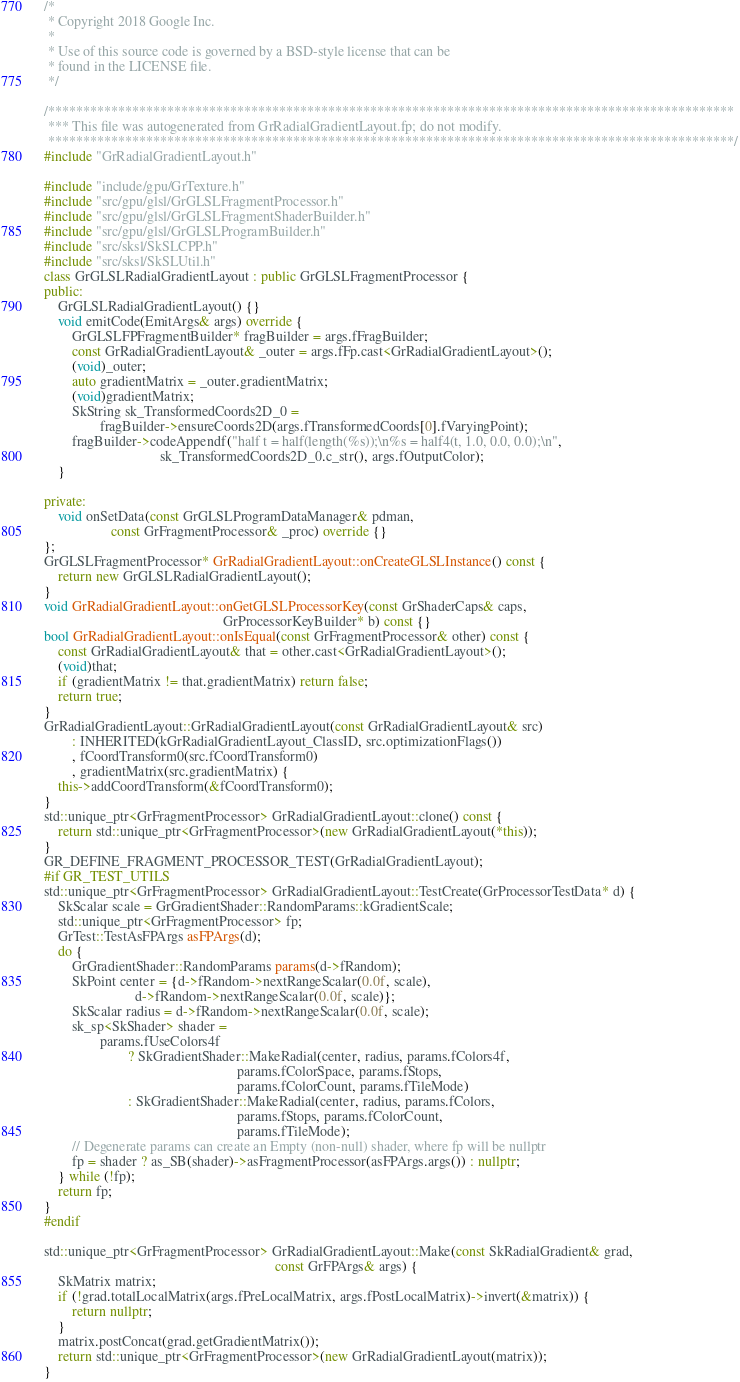<code> <loc_0><loc_0><loc_500><loc_500><_C++_>/*
 * Copyright 2018 Google Inc.
 *
 * Use of this source code is governed by a BSD-style license that can be
 * found in the LICENSE file.
 */

/**************************************************************************************************
 *** This file was autogenerated from GrRadialGradientLayout.fp; do not modify.
 **************************************************************************************************/
#include "GrRadialGradientLayout.h"

#include "include/gpu/GrTexture.h"
#include "src/gpu/glsl/GrGLSLFragmentProcessor.h"
#include "src/gpu/glsl/GrGLSLFragmentShaderBuilder.h"
#include "src/gpu/glsl/GrGLSLProgramBuilder.h"
#include "src/sksl/SkSLCPP.h"
#include "src/sksl/SkSLUtil.h"
class GrGLSLRadialGradientLayout : public GrGLSLFragmentProcessor {
public:
    GrGLSLRadialGradientLayout() {}
    void emitCode(EmitArgs& args) override {
        GrGLSLFPFragmentBuilder* fragBuilder = args.fFragBuilder;
        const GrRadialGradientLayout& _outer = args.fFp.cast<GrRadialGradientLayout>();
        (void)_outer;
        auto gradientMatrix = _outer.gradientMatrix;
        (void)gradientMatrix;
        SkString sk_TransformedCoords2D_0 =
                fragBuilder->ensureCoords2D(args.fTransformedCoords[0].fVaryingPoint);
        fragBuilder->codeAppendf("half t = half(length(%s));\n%s = half4(t, 1.0, 0.0, 0.0);\n",
                                 sk_TransformedCoords2D_0.c_str(), args.fOutputColor);
    }

private:
    void onSetData(const GrGLSLProgramDataManager& pdman,
                   const GrFragmentProcessor& _proc) override {}
};
GrGLSLFragmentProcessor* GrRadialGradientLayout::onCreateGLSLInstance() const {
    return new GrGLSLRadialGradientLayout();
}
void GrRadialGradientLayout::onGetGLSLProcessorKey(const GrShaderCaps& caps,
                                                   GrProcessorKeyBuilder* b) const {}
bool GrRadialGradientLayout::onIsEqual(const GrFragmentProcessor& other) const {
    const GrRadialGradientLayout& that = other.cast<GrRadialGradientLayout>();
    (void)that;
    if (gradientMatrix != that.gradientMatrix) return false;
    return true;
}
GrRadialGradientLayout::GrRadialGradientLayout(const GrRadialGradientLayout& src)
        : INHERITED(kGrRadialGradientLayout_ClassID, src.optimizationFlags())
        , fCoordTransform0(src.fCoordTransform0)
        , gradientMatrix(src.gradientMatrix) {
    this->addCoordTransform(&fCoordTransform0);
}
std::unique_ptr<GrFragmentProcessor> GrRadialGradientLayout::clone() const {
    return std::unique_ptr<GrFragmentProcessor>(new GrRadialGradientLayout(*this));
}
GR_DEFINE_FRAGMENT_PROCESSOR_TEST(GrRadialGradientLayout);
#if GR_TEST_UTILS
std::unique_ptr<GrFragmentProcessor> GrRadialGradientLayout::TestCreate(GrProcessorTestData* d) {
    SkScalar scale = GrGradientShader::RandomParams::kGradientScale;
    std::unique_ptr<GrFragmentProcessor> fp;
    GrTest::TestAsFPArgs asFPArgs(d);
    do {
        GrGradientShader::RandomParams params(d->fRandom);
        SkPoint center = {d->fRandom->nextRangeScalar(0.0f, scale),
                          d->fRandom->nextRangeScalar(0.0f, scale)};
        SkScalar radius = d->fRandom->nextRangeScalar(0.0f, scale);
        sk_sp<SkShader> shader =
                params.fUseColors4f
                        ? SkGradientShader::MakeRadial(center, radius, params.fColors4f,
                                                       params.fColorSpace, params.fStops,
                                                       params.fColorCount, params.fTileMode)
                        : SkGradientShader::MakeRadial(center, radius, params.fColors,
                                                       params.fStops, params.fColorCount,
                                                       params.fTileMode);
        // Degenerate params can create an Empty (non-null) shader, where fp will be nullptr
        fp = shader ? as_SB(shader)->asFragmentProcessor(asFPArgs.args()) : nullptr;
    } while (!fp);
    return fp;
}
#endif

std::unique_ptr<GrFragmentProcessor> GrRadialGradientLayout::Make(const SkRadialGradient& grad,
                                                                  const GrFPArgs& args) {
    SkMatrix matrix;
    if (!grad.totalLocalMatrix(args.fPreLocalMatrix, args.fPostLocalMatrix)->invert(&matrix)) {
        return nullptr;
    }
    matrix.postConcat(grad.getGradientMatrix());
    return std::unique_ptr<GrFragmentProcessor>(new GrRadialGradientLayout(matrix));
}
</code> 